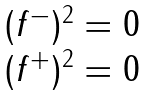Convert formula to latex. <formula><loc_0><loc_0><loc_500><loc_500>\begin{array} { c } { { ( f ^ { - } ) ^ { 2 } = 0 } } \\ { { ( f ^ { + } ) ^ { 2 } = 0 } } \end{array}</formula> 